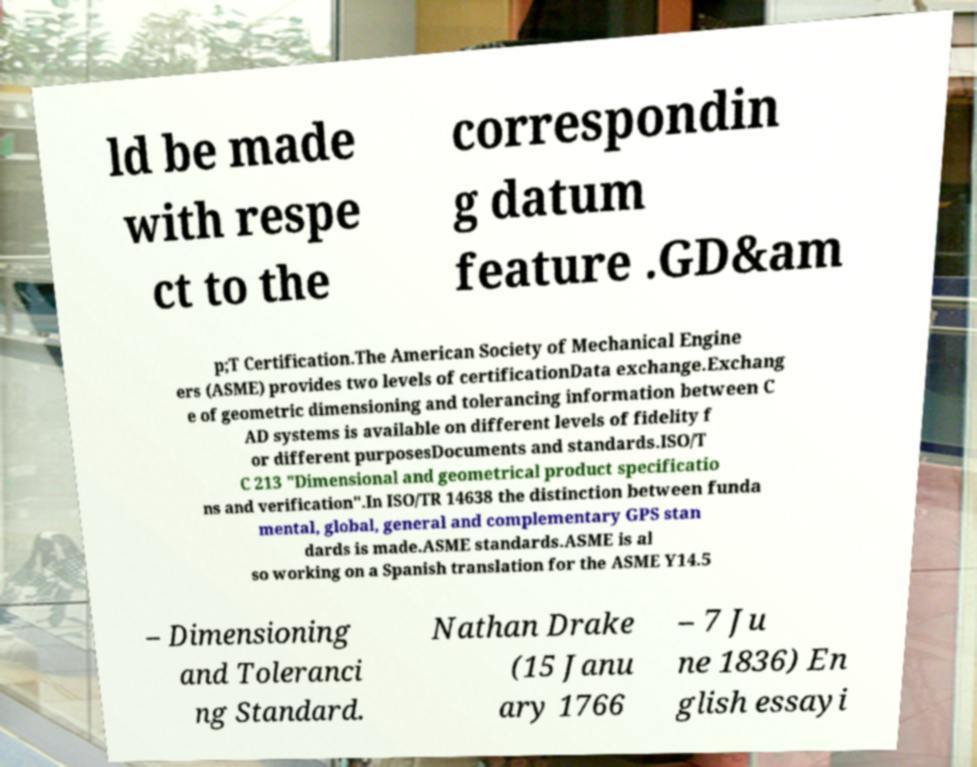For documentation purposes, I need the text within this image transcribed. Could you provide that? ld be made with respe ct to the correspondin g datum feature .GD&am p;T Certification.The American Society of Mechanical Engine ers (ASME) provides two levels of certificationData exchange.Exchang e of geometric dimensioning and tolerancing information between C AD systems is available on different levels of fidelity f or different purposesDocuments and standards.ISO/T C 213 "Dimensional and geometrical product specificatio ns and verification".In ISO/TR 14638 the distinction between funda mental, global, general and complementary GPS stan dards is made.ASME standards.ASME is al so working on a Spanish translation for the ASME Y14.5 – Dimensioning and Toleranci ng Standard. Nathan Drake (15 Janu ary 1766 – 7 Ju ne 1836) En glish essayi 